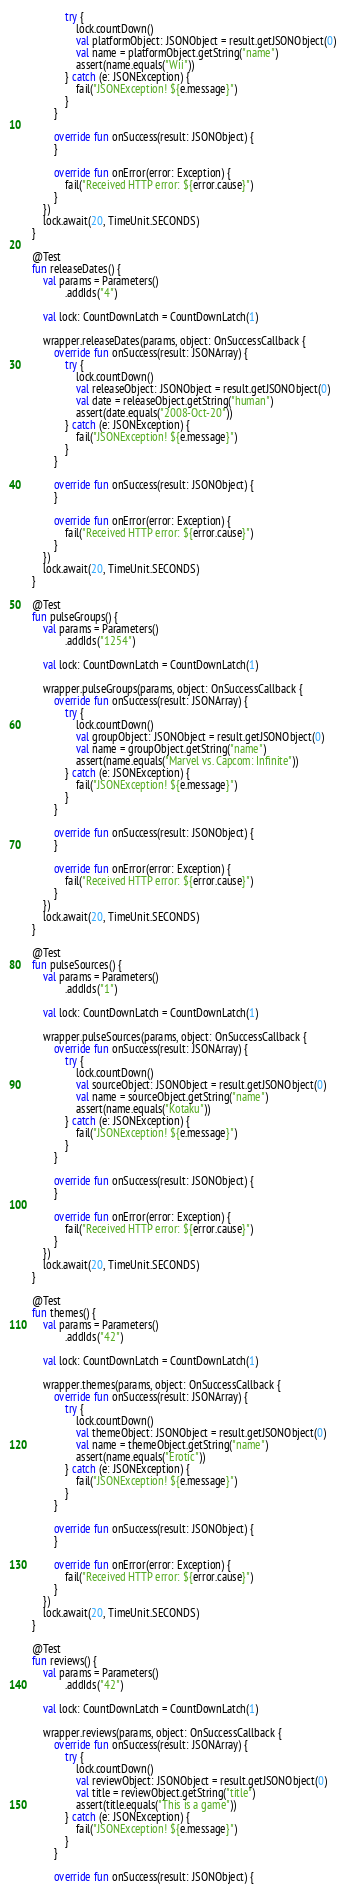Convert code to text. <code><loc_0><loc_0><loc_500><loc_500><_Kotlin_>                try {
                    lock.countDown()
                    val platformObject: JSONObject = result.getJSONObject(0)
                    val name = platformObject.getString("name")
                    assert(name.equals("Wii"))
                } catch (e: JSONException) {
                    fail("JSONException! ${e.message}")
                }
            }

            override fun onSuccess(result: JSONObject) {
            }

            override fun onError(error: Exception) {
                fail("Received HTTP error: ${error.cause}")
            }
        })
        lock.await(20, TimeUnit.SECONDS)
    }

    @Test
    fun releaseDates() {
        val params = Parameters()
                .addIds("4")

        val lock: CountDownLatch = CountDownLatch(1)

        wrapper.releaseDates(params, object: OnSuccessCallback {
            override fun onSuccess(result: JSONArray) {
                try {
                    lock.countDown()
                    val releaseObject: JSONObject = result.getJSONObject(0)
                    val date = releaseObject.getString("human")
                    assert(date.equals("2008-Oct-20"))
                } catch (e: JSONException) {
                    fail("JSONException! ${e.message}")
                }
            }

            override fun onSuccess(result: JSONObject) {
            }

            override fun onError(error: Exception) {
                fail("Received HTTP error: ${error.cause}")
            }
        })
        lock.await(20, TimeUnit.SECONDS)
    }

    @Test
    fun pulseGroups() {
        val params = Parameters()
                .addIds("1254")

        val lock: CountDownLatch = CountDownLatch(1)

        wrapper.pulseGroups(params, object: OnSuccessCallback {
            override fun onSuccess(result: JSONArray) {
                try {
                    lock.countDown()
                    val groupObject: JSONObject = result.getJSONObject(0)
                    val name = groupObject.getString("name")
                    assert(name.equals("Marvel vs. Capcom: Infinite"))
                } catch (e: JSONException) {
                    fail("JSONException! ${e.message}")
                }
            }

            override fun onSuccess(result: JSONObject) {
            }

            override fun onError(error: Exception) {
                fail("Received HTTP error: ${error.cause}")
            }
        })
        lock.await(20, TimeUnit.SECONDS)
    }

    @Test
    fun pulseSources() {
        val params = Parameters()
                .addIds("1")

        val lock: CountDownLatch = CountDownLatch(1)

        wrapper.pulseSources(params, object: OnSuccessCallback {
            override fun onSuccess(result: JSONArray) {
                try {
                    lock.countDown()
                    val sourceObject: JSONObject = result.getJSONObject(0)
                    val name = sourceObject.getString("name")
                    assert(name.equals("Kotaku"))
                } catch (e: JSONException) {
                    fail("JSONException! ${e.message}")
                }
            }

            override fun onSuccess(result: JSONObject) {
            }

            override fun onError(error: Exception) {
                fail("Received HTTP error: ${error.cause}")
            }
        })
        lock.await(20, TimeUnit.SECONDS)
    }

    @Test
    fun themes() {
        val params = Parameters()
                .addIds("42")

        val lock: CountDownLatch = CountDownLatch(1)

        wrapper.themes(params, object: OnSuccessCallback {
            override fun onSuccess(result: JSONArray) {
                try {
                    lock.countDown()
                    val themeObject: JSONObject = result.getJSONObject(0)
                    val name = themeObject.getString("name")
                    assert(name.equals("Erotic"))
                } catch (e: JSONException) {
                    fail("JSONException! ${e.message}")
                }
            }

            override fun onSuccess(result: JSONObject) {
            }

            override fun onError(error: Exception) {
                fail("Received HTTP error: ${error.cause}")
            }
        })
        lock.await(20, TimeUnit.SECONDS)
    }

    @Test
    fun reviews() {
        val params = Parameters()
                .addIds("42")

        val lock: CountDownLatch = CountDownLatch(1)

        wrapper.reviews(params, object: OnSuccessCallback {
            override fun onSuccess(result: JSONArray) {
                try {
                    lock.countDown()
                    val reviewObject: JSONObject = result.getJSONObject(0)
                    val title = reviewObject.getString("title")
                    assert(title.equals("This is a game"))
                } catch (e: JSONException) {
                    fail("JSONException! ${e.message}")
                }
            }

            override fun onSuccess(result: JSONObject) {</code> 